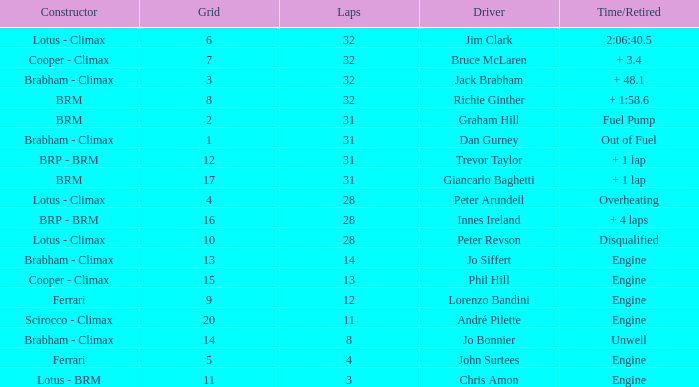What is the average grid for jack brabham going over 32 laps? None. 